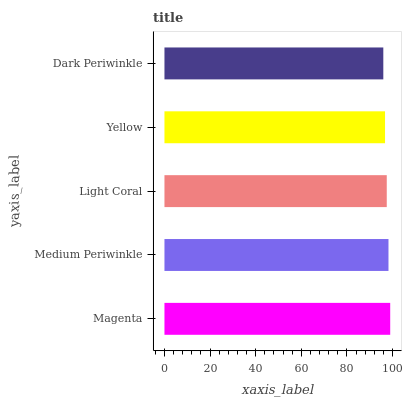Is Dark Periwinkle the minimum?
Answer yes or no. Yes. Is Magenta the maximum?
Answer yes or no. Yes. Is Medium Periwinkle the minimum?
Answer yes or no. No. Is Medium Periwinkle the maximum?
Answer yes or no. No. Is Magenta greater than Medium Periwinkle?
Answer yes or no. Yes. Is Medium Periwinkle less than Magenta?
Answer yes or no. Yes. Is Medium Periwinkle greater than Magenta?
Answer yes or no. No. Is Magenta less than Medium Periwinkle?
Answer yes or no. No. Is Light Coral the high median?
Answer yes or no. Yes. Is Light Coral the low median?
Answer yes or no. Yes. Is Dark Periwinkle the high median?
Answer yes or no. No. Is Yellow the low median?
Answer yes or no. No. 